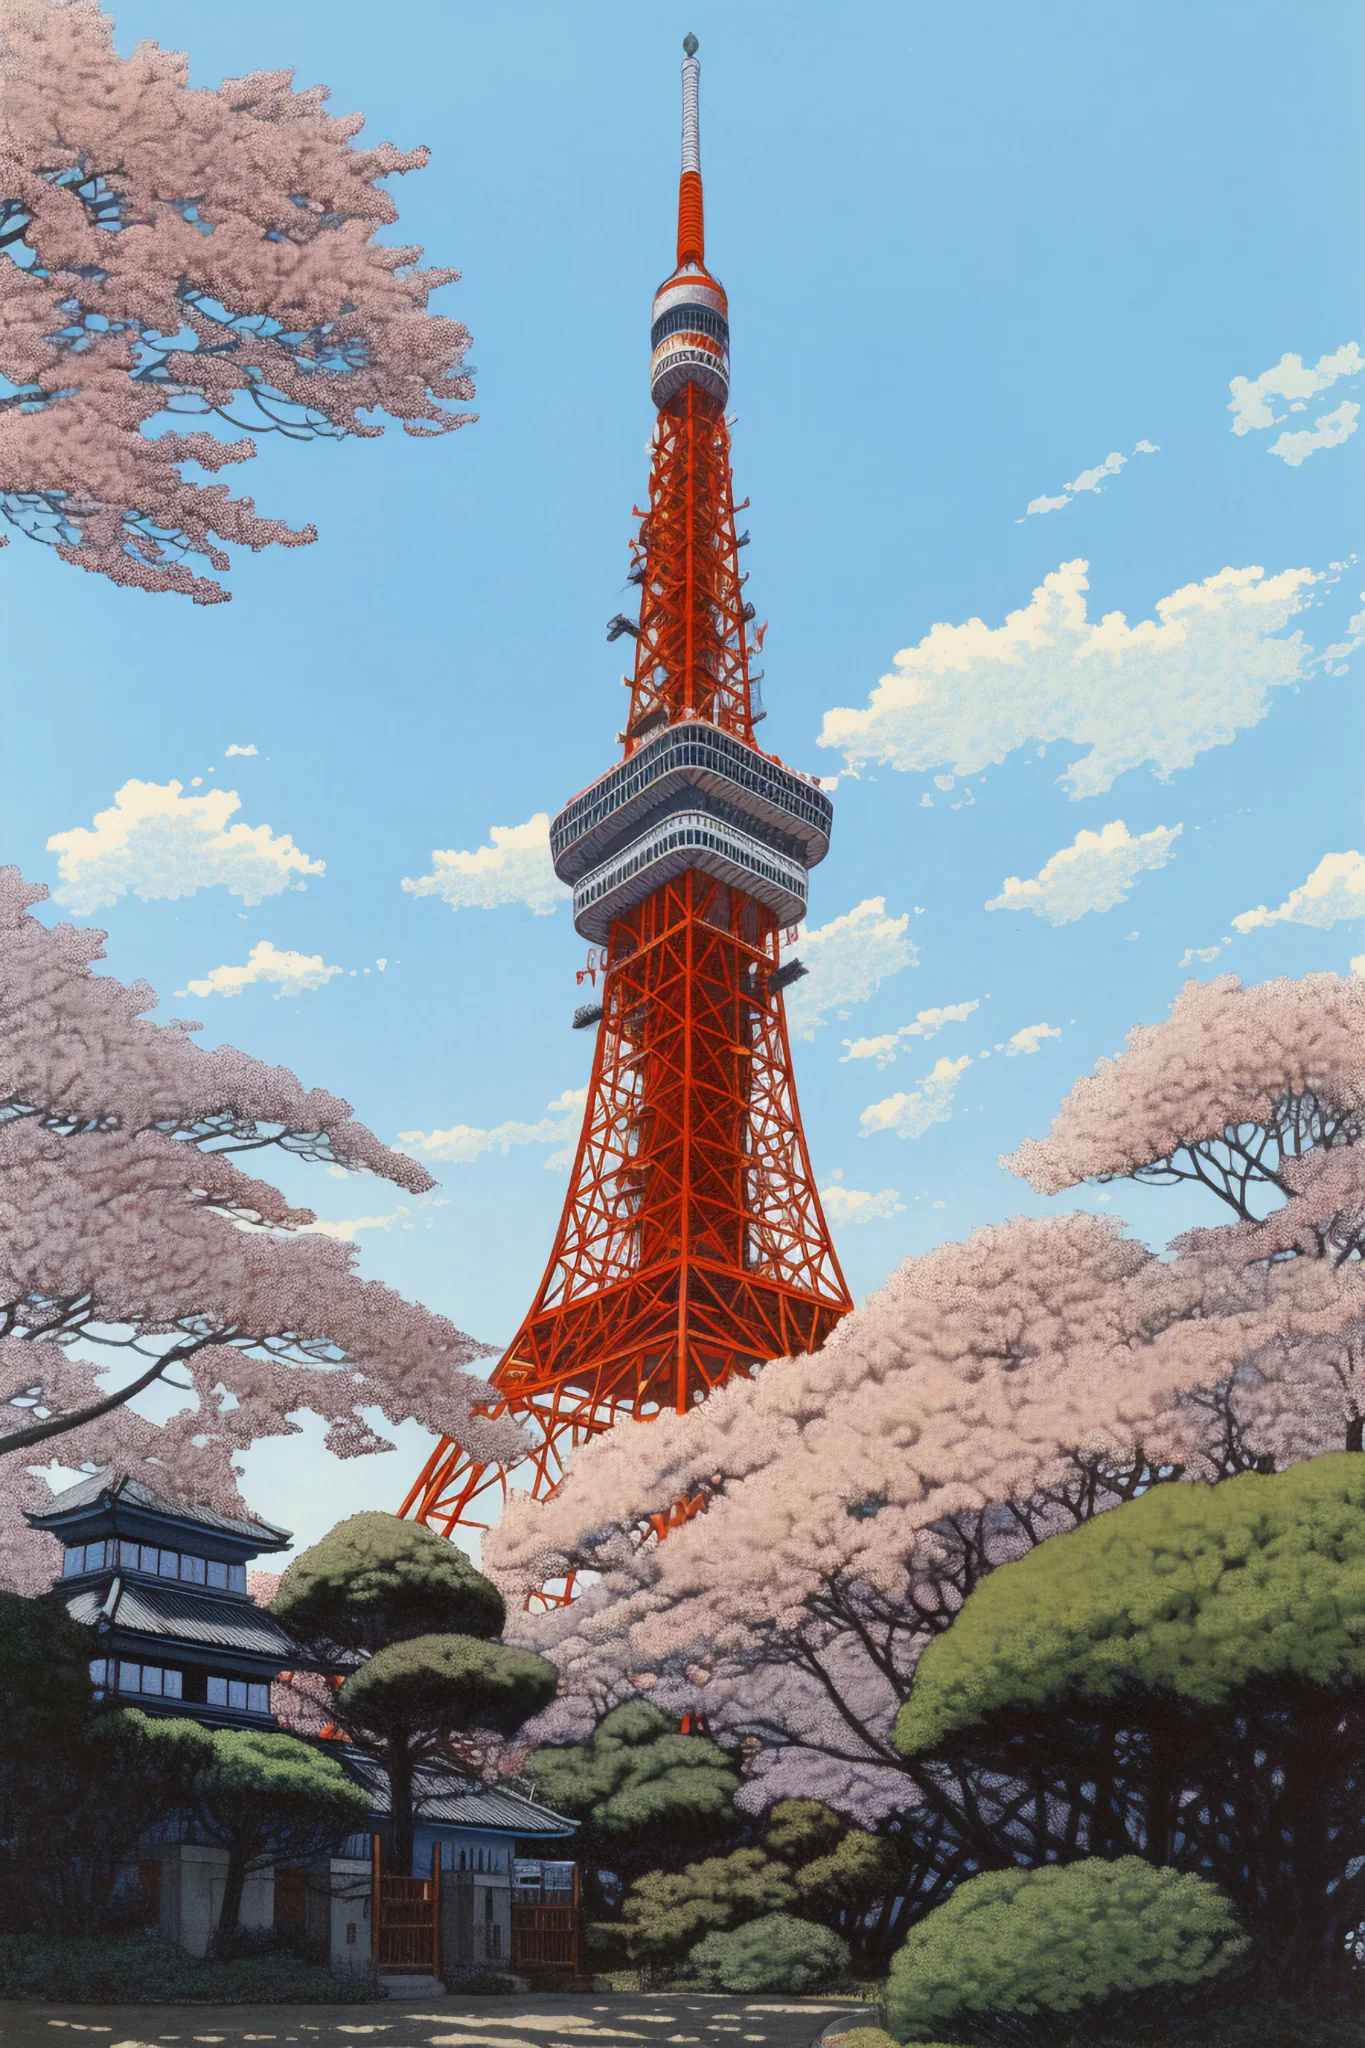What are the key elements in this picture? The image showcases the iconic Tokyo Tower, brilliantly painted in vibrant orange and standing tall against a pristine blue sky. We are looking at the tower from a low angle, which accentuates its towering stature. The scene is enriched by the presence of numerous cherry blossom trees in full bloom, their soft pink petals creating a beautiful contrast with the steel structure of the tower. Additionally, green shrubbery provides a touch of nature at the base, and a traditional-looking building is partially visible on the left side, blending urban and natural elements harmoniously. 